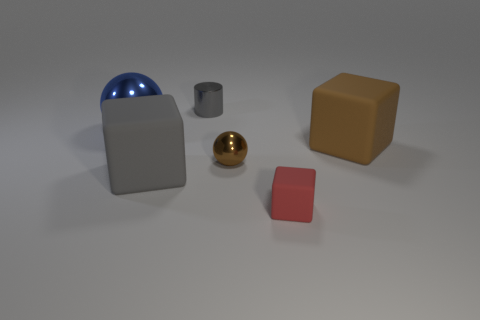Are there any other things that are the same size as the gray metallic object?
Make the answer very short. Yes. There is a big block that is the same color as the small metal cylinder; what is its material?
Provide a succinct answer. Rubber. What number of other things are the same color as the big shiny thing?
Make the answer very short. 0. Do the gray matte object and the object that is behind the big blue ball have the same size?
Make the answer very short. No. There is a sphere in front of the rubber thing that is behind the large cube that is left of the small cylinder; what is its size?
Provide a short and direct response. Small. What number of gray shiny cylinders are behind the large brown block?
Offer a very short reply. 1. What material is the big thing that is right of the gray thing that is behind the large blue thing made of?
Your answer should be compact. Rubber. Does the red cube have the same size as the gray cube?
Your response must be concise. No. What number of things are small objects behind the tiny metallic sphere or objects that are on the right side of the gray metallic object?
Ensure brevity in your answer.  4. Is the number of gray cylinders that are behind the gray cylinder greater than the number of gray rubber cubes?
Give a very brief answer. No. 